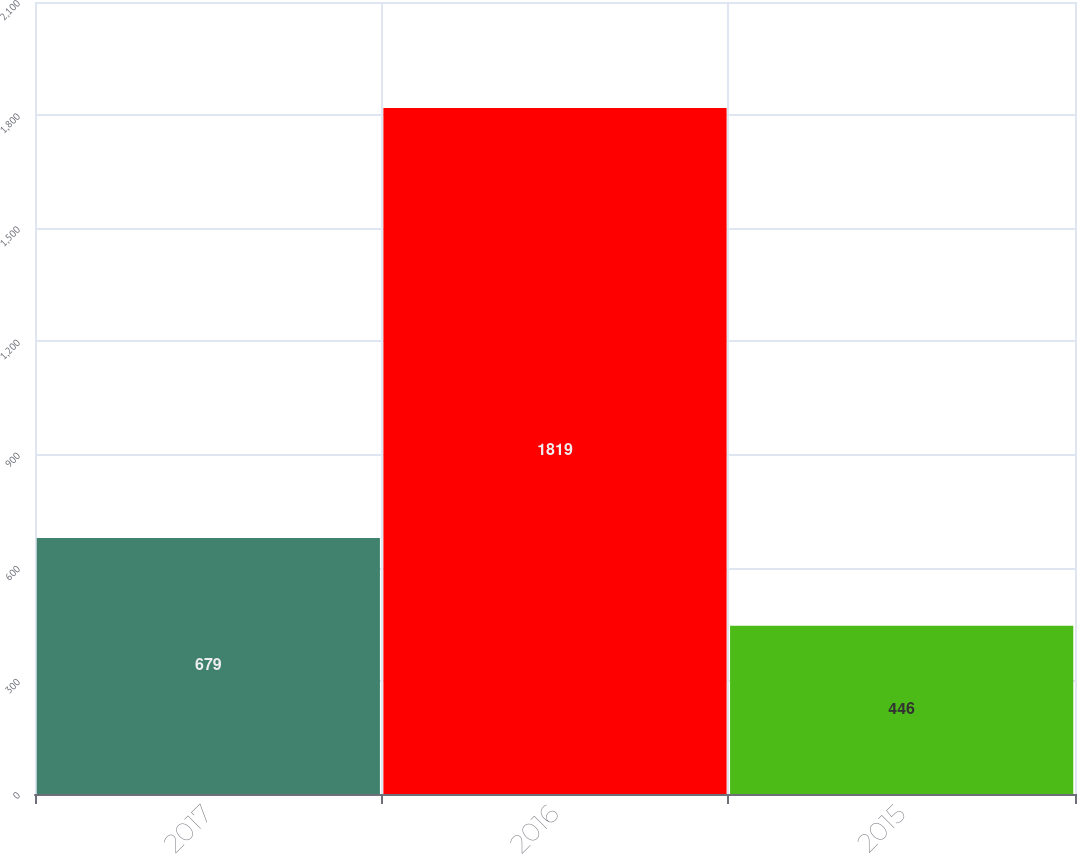Convert chart. <chart><loc_0><loc_0><loc_500><loc_500><bar_chart><fcel>2017<fcel>2016<fcel>2015<nl><fcel>679<fcel>1819<fcel>446<nl></chart> 